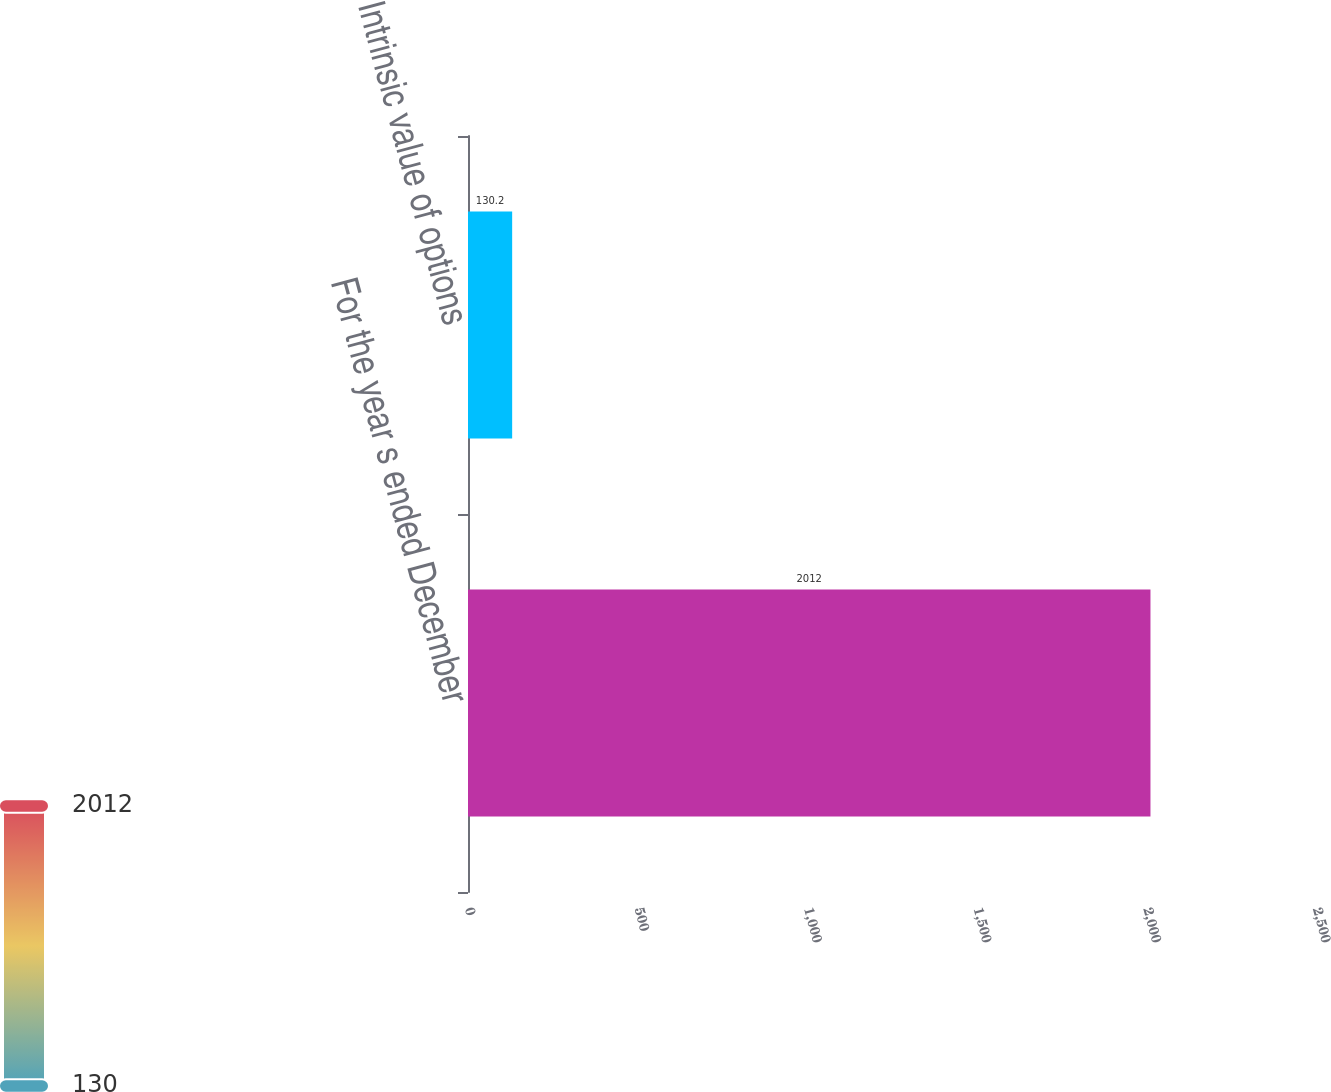Convert chart. <chart><loc_0><loc_0><loc_500><loc_500><bar_chart><fcel>For the year s ended December<fcel>Intrinsic value of options<nl><fcel>2012<fcel>130.2<nl></chart> 